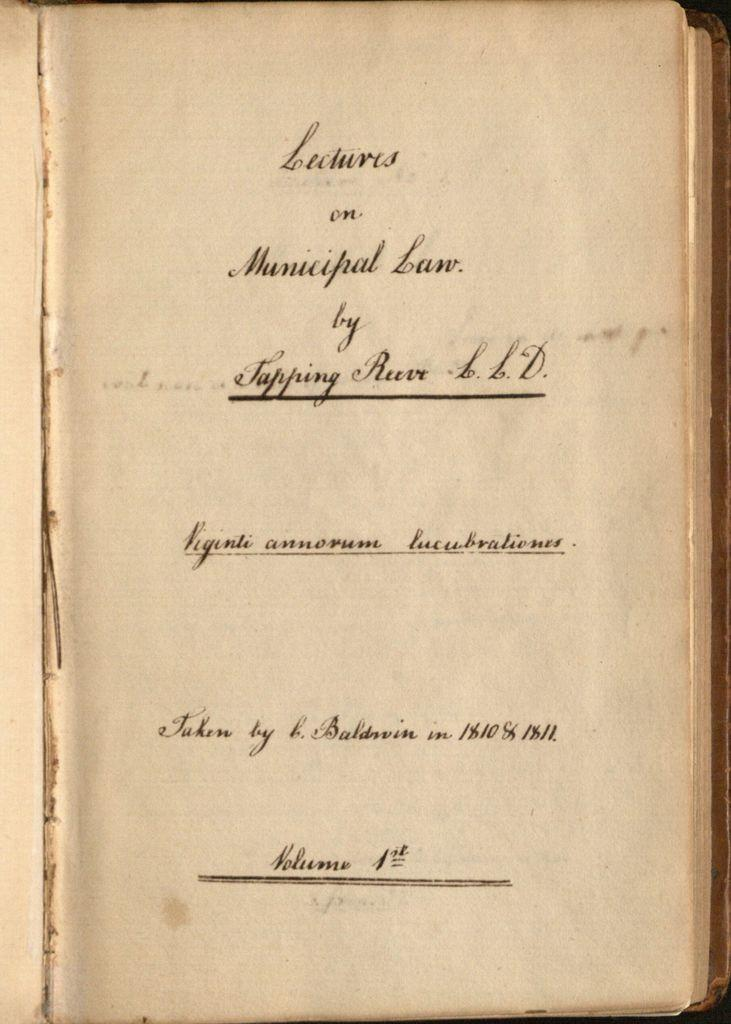<image>
Create a compact narrative representing the image presented. A book is open to a page that says Lectures on Municipal Law. 